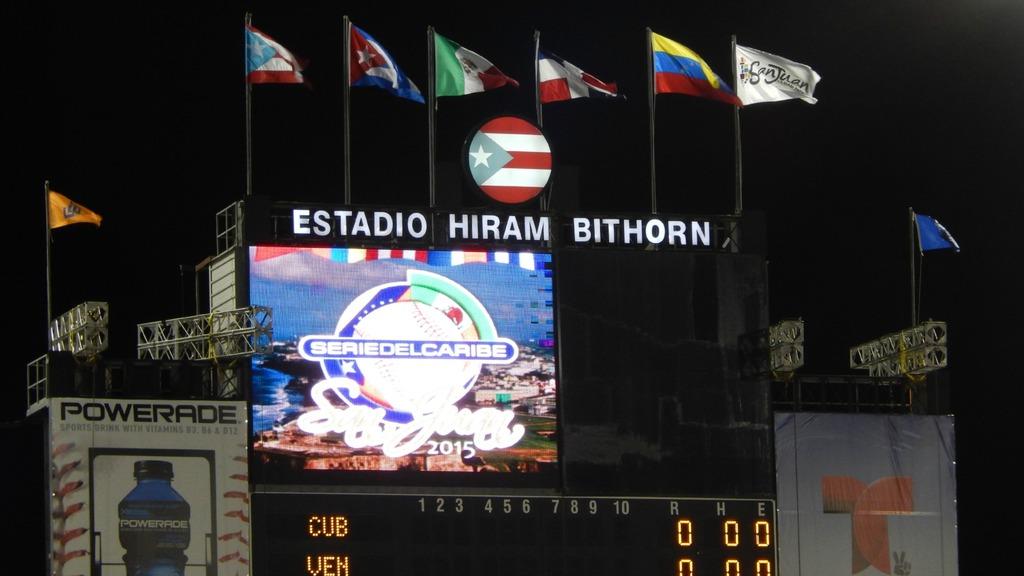What is the name of the sports drink on the left?
Your answer should be compact. Powerade. What is written on the top of the billboard?
Provide a short and direct response. Estadio hiram bithorn. 